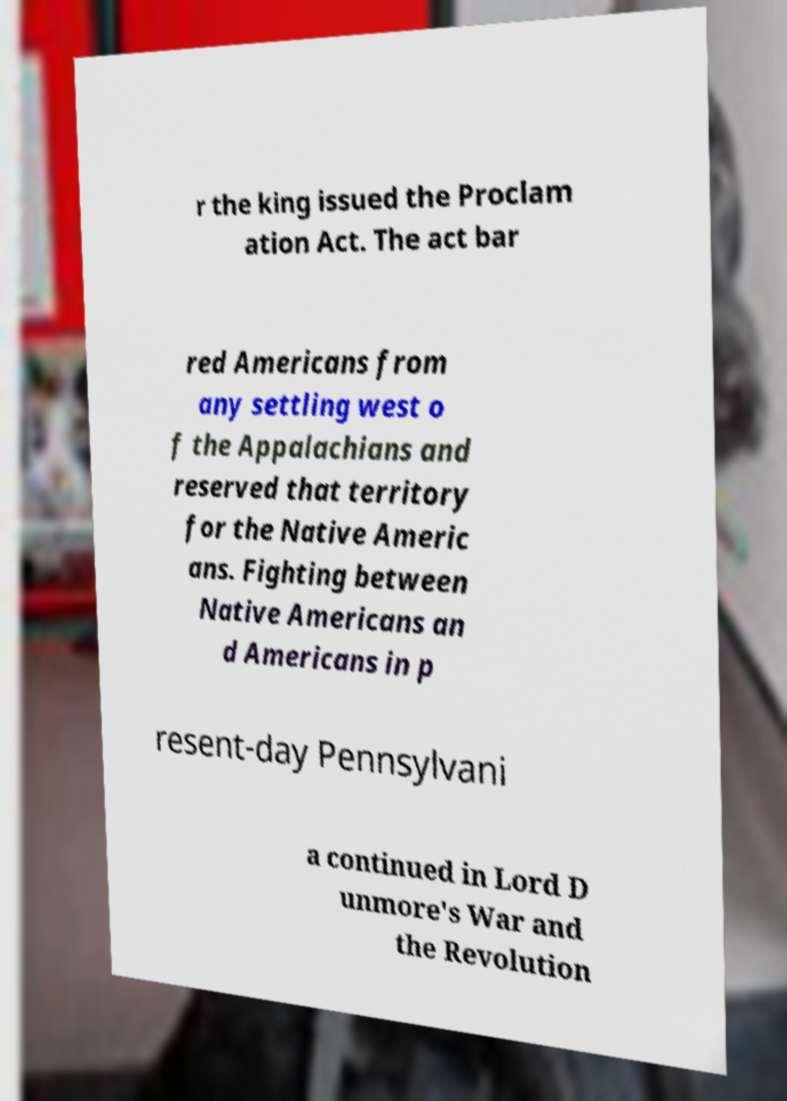Could you extract and type out the text from this image? r the king issued the Proclam ation Act. The act bar red Americans from any settling west o f the Appalachians and reserved that territory for the Native Americ ans. Fighting between Native Americans an d Americans in p resent-day Pennsylvani a continued in Lord D unmore's War and the Revolution 